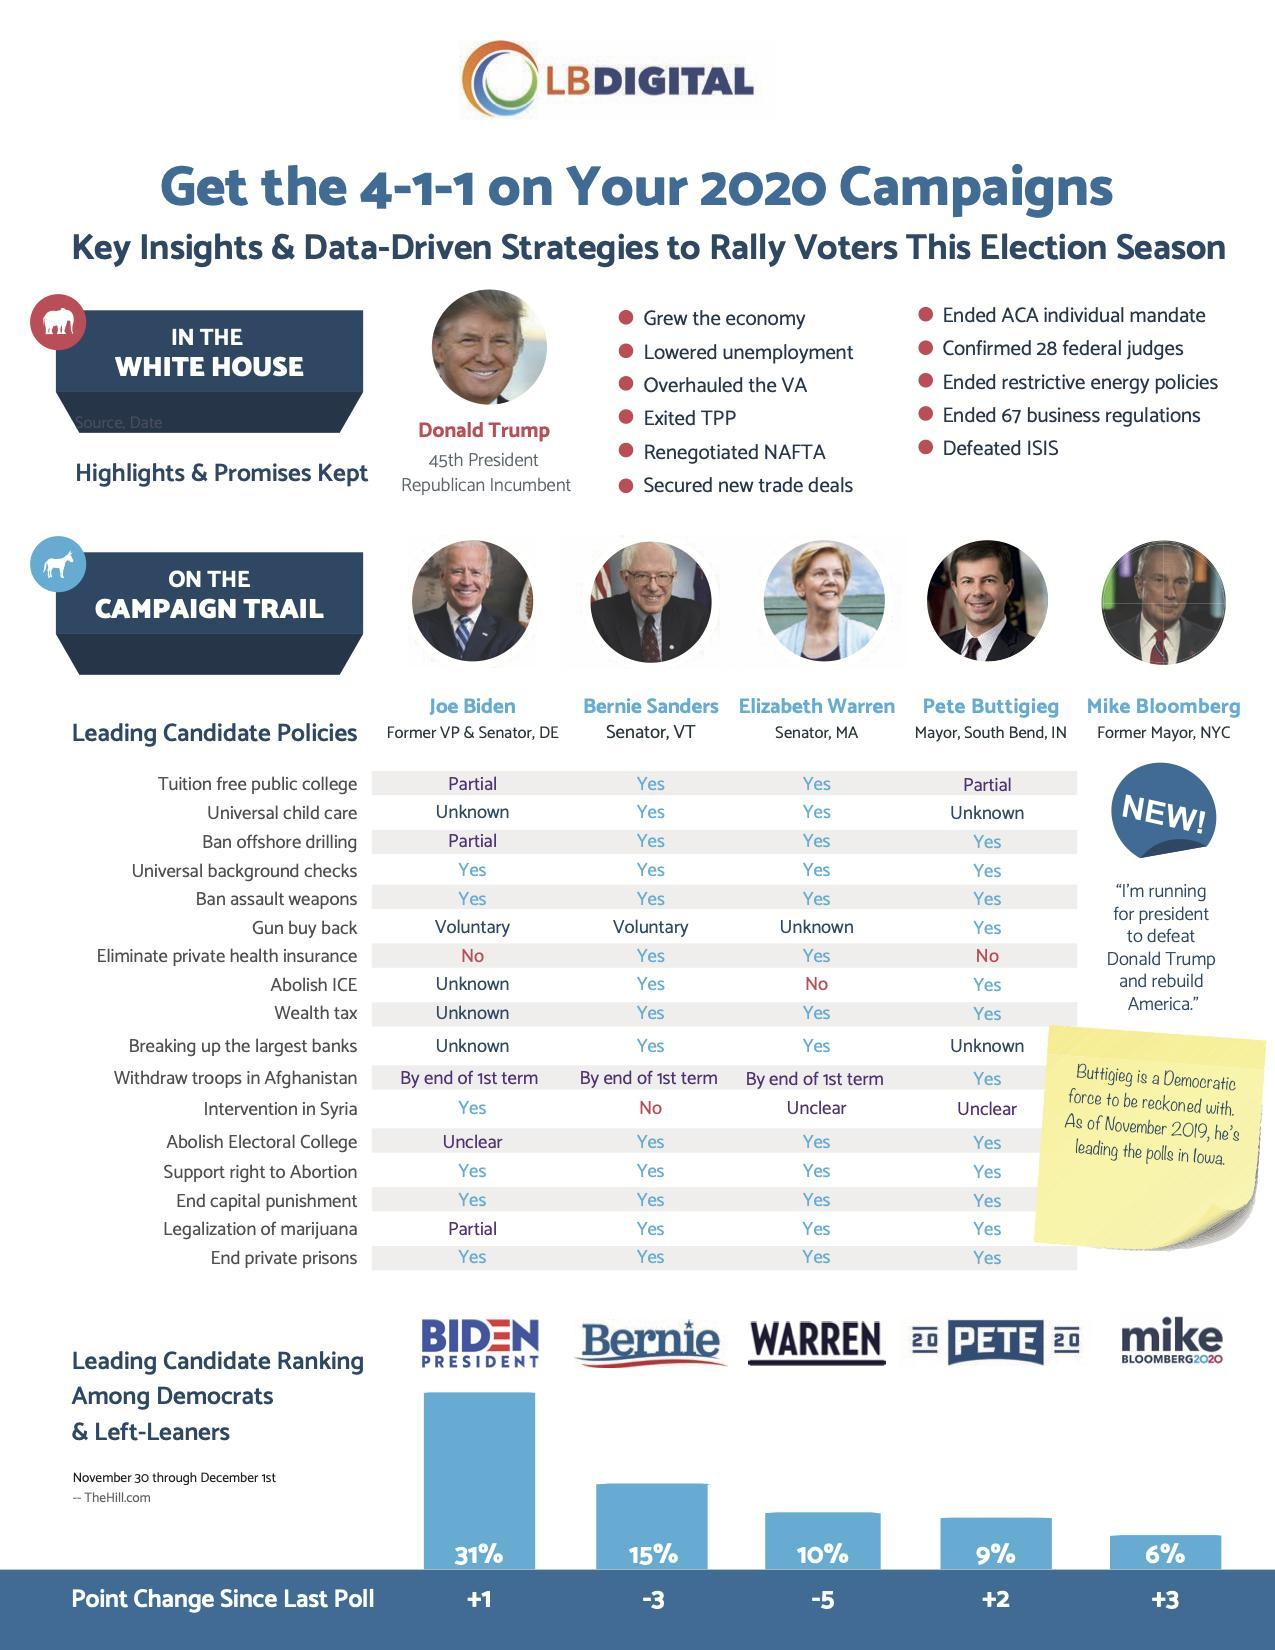Which policy is discouraged by Joe Biden?
Answer the question with a short phrase. Eliminate private health insurance Which candidate is a Former Mayor in New York City? Mike Bloomberg How many candidates said NO to "Eliminate private health insurance"? 2 Which candidate has the second-highest chance to win the presidential election? Bernie 